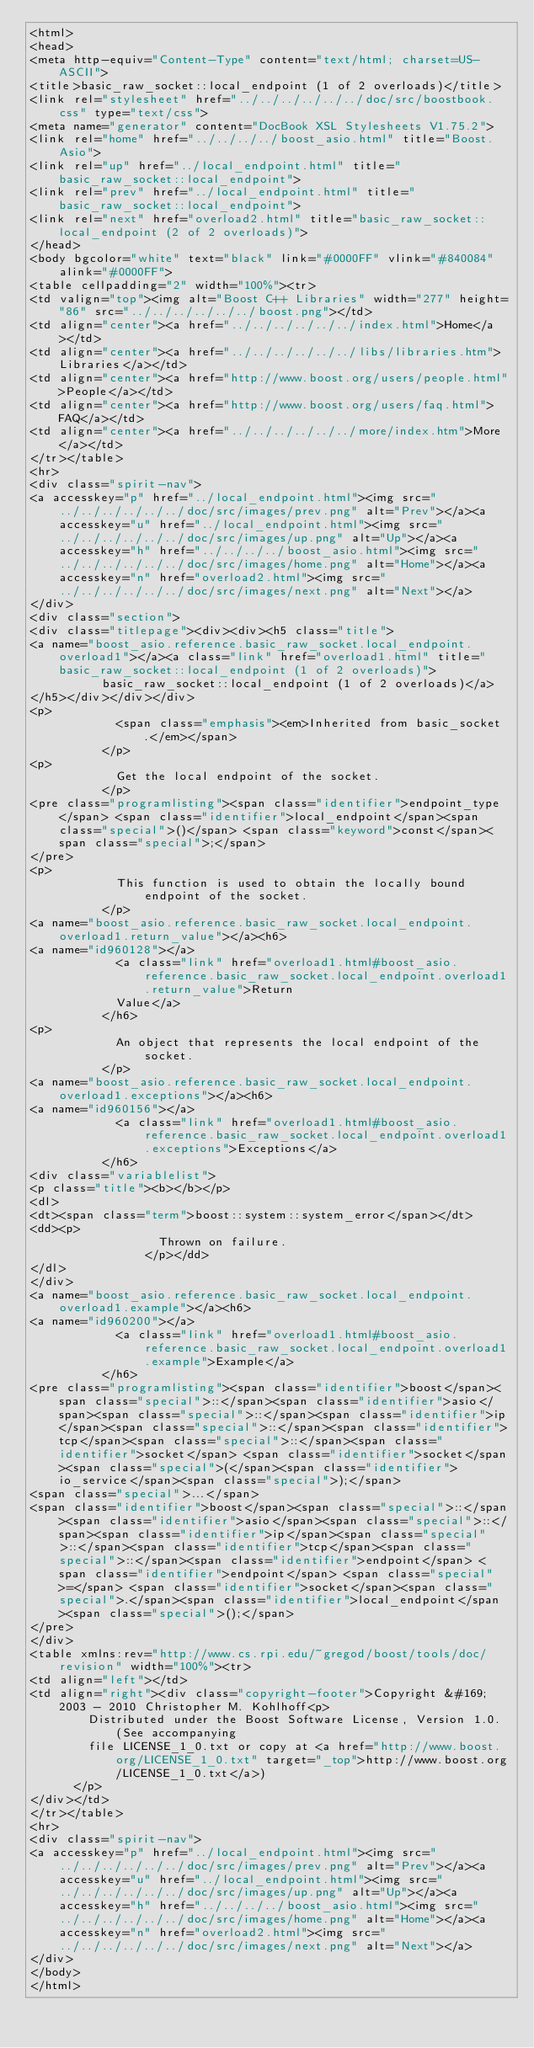Convert code to text. <code><loc_0><loc_0><loc_500><loc_500><_HTML_><html>
<head>
<meta http-equiv="Content-Type" content="text/html; charset=US-ASCII">
<title>basic_raw_socket::local_endpoint (1 of 2 overloads)</title>
<link rel="stylesheet" href="../../../../../../doc/src/boostbook.css" type="text/css">
<meta name="generator" content="DocBook XSL Stylesheets V1.75.2">
<link rel="home" href="../../../../boost_asio.html" title="Boost.Asio">
<link rel="up" href="../local_endpoint.html" title="basic_raw_socket::local_endpoint">
<link rel="prev" href="../local_endpoint.html" title="basic_raw_socket::local_endpoint">
<link rel="next" href="overload2.html" title="basic_raw_socket::local_endpoint (2 of 2 overloads)">
</head>
<body bgcolor="white" text="black" link="#0000FF" vlink="#840084" alink="#0000FF">
<table cellpadding="2" width="100%"><tr>
<td valign="top"><img alt="Boost C++ Libraries" width="277" height="86" src="../../../../../../boost.png"></td>
<td align="center"><a href="../../../../../../index.html">Home</a></td>
<td align="center"><a href="../../../../../../libs/libraries.htm">Libraries</a></td>
<td align="center"><a href="http://www.boost.org/users/people.html">People</a></td>
<td align="center"><a href="http://www.boost.org/users/faq.html">FAQ</a></td>
<td align="center"><a href="../../../../../../more/index.htm">More</a></td>
</tr></table>
<hr>
<div class="spirit-nav">
<a accesskey="p" href="../local_endpoint.html"><img src="../../../../../../doc/src/images/prev.png" alt="Prev"></a><a accesskey="u" href="../local_endpoint.html"><img src="../../../../../../doc/src/images/up.png" alt="Up"></a><a accesskey="h" href="../../../../boost_asio.html"><img src="../../../../../../doc/src/images/home.png" alt="Home"></a><a accesskey="n" href="overload2.html"><img src="../../../../../../doc/src/images/next.png" alt="Next"></a>
</div>
<div class="section">
<div class="titlepage"><div><div><h5 class="title">
<a name="boost_asio.reference.basic_raw_socket.local_endpoint.overload1"></a><a class="link" href="overload1.html" title="basic_raw_socket::local_endpoint (1 of 2 overloads)">
          basic_raw_socket::local_endpoint (1 of 2 overloads)</a>
</h5></div></div></div>
<p>
            <span class="emphasis"><em>Inherited from basic_socket.</em></span>
          </p>
<p>
            Get the local endpoint of the socket.
          </p>
<pre class="programlisting"><span class="identifier">endpoint_type</span> <span class="identifier">local_endpoint</span><span class="special">()</span> <span class="keyword">const</span><span class="special">;</span>
</pre>
<p>
            This function is used to obtain the locally bound endpoint of the socket.
          </p>
<a name="boost_asio.reference.basic_raw_socket.local_endpoint.overload1.return_value"></a><h6>
<a name="id960128"></a>
            <a class="link" href="overload1.html#boost_asio.reference.basic_raw_socket.local_endpoint.overload1.return_value">Return
            Value</a>
          </h6>
<p>
            An object that represents the local endpoint of the socket.
          </p>
<a name="boost_asio.reference.basic_raw_socket.local_endpoint.overload1.exceptions"></a><h6>
<a name="id960156"></a>
            <a class="link" href="overload1.html#boost_asio.reference.basic_raw_socket.local_endpoint.overload1.exceptions">Exceptions</a>
          </h6>
<div class="variablelist">
<p class="title"><b></b></p>
<dl>
<dt><span class="term">boost::system::system_error</span></dt>
<dd><p>
                  Thrown on failure.
                </p></dd>
</dl>
</div>
<a name="boost_asio.reference.basic_raw_socket.local_endpoint.overload1.example"></a><h6>
<a name="id960200"></a>
            <a class="link" href="overload1.html#boost_asio.reference.basic_raw_socket.local_endpoint.overload1.example">Example</a>
          </h6>
<pre class="programlisting"><span class="identifier">boost</span><span class="special">::</span><span class="identifier">asio</span><span class="special">::</span><span class="identifier">ip</span><span class="special">::</span><span class="identifier">tcp</span><span class="special">::</span><span class="identifier">socket</span> <span class="identifier">socket</span><span class="special">(</span><span class="identifier">io_service</span><span class="special">);</span>
<span class="special">...</span>
<span class="identifier">boost</span><span class="special">::</span><span class="identifier">asio</span><span class="special">::</span><span class="identifier">ip</span><span class="special">::</span><span class="identifier">tcp</span><span class="special">::</span><span class="identifier">endpoint</span> <span class="identifier">endpoint</span> <span class="special">=</span> <span class="identifier">socket</span><span class="special">.</span><span class="identifier">local_endpoint</span><span class="special">();</span>
</pre>
</div>
<table xmlns:rev="http://www.cs.rpi.edu/~gregod/boost/tools/doc/revision" width="100%"><tr>
<td align="left"></td>
<td align="right"><div class="copyright-footer">Copyright &#169; 2003 - 2010 Christopher M. Kohlhoff<p>
        Distributed under the Boost Software License, Version 1.0. (See accompanying
        file LICENSE_1_0.txt or copy at <a href="http://www.boost.org/LICENSE_1_0.txt" target="_top">http://www.boost.org/LICENSE_1_0.txt</a>)
      </p>
</div></td>
</tr></table>
<hr>
<div class="spirit-nav">
<a accesskey="p" href="../local_endpoint.html"><img src="../../../../../../doc/src/images/prev.png" alt="Prev"></a><a accesskey="u" href="../local_endpoint.html"><img src="../../../../../../doc/src/images/up.png" alt="Up"></a><a accesskey="h" href="../../../../boost_asio.html"><img src="../../../../../../doc/src/images/home.png" alt="Home"></a><a accesskey="n" href="overload2.html"><img src="../../../../../../doc/src/images/next.png" alt="Next"></a>
</div>
</body>
</html>
</code> 